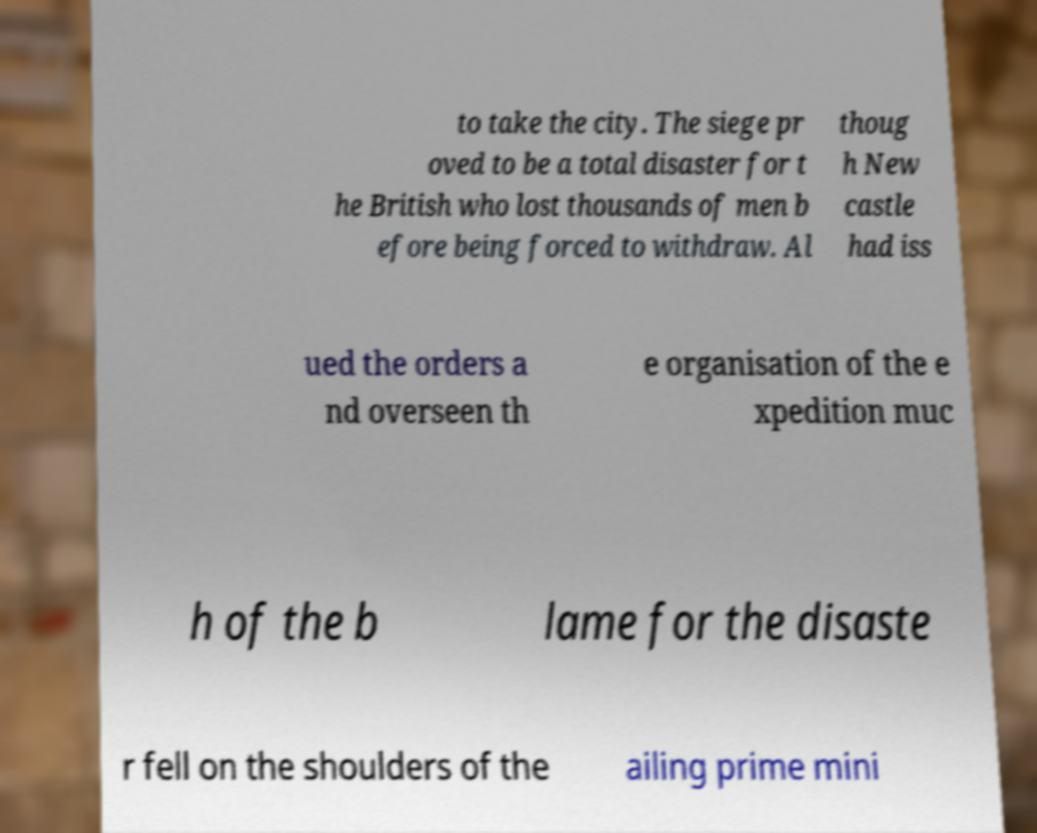Could you extract and type out the text from this image? to take the city. The siege pr oved to be a total disaster for t he British who lost thousands of men b efore being forced to withdraw. Al thoug h New castle had iss ued the orders a nd overseen th e organisation of the e xpedition muc h of the b lame for the disaste r fell on the shoulders of the ailing prime mini 